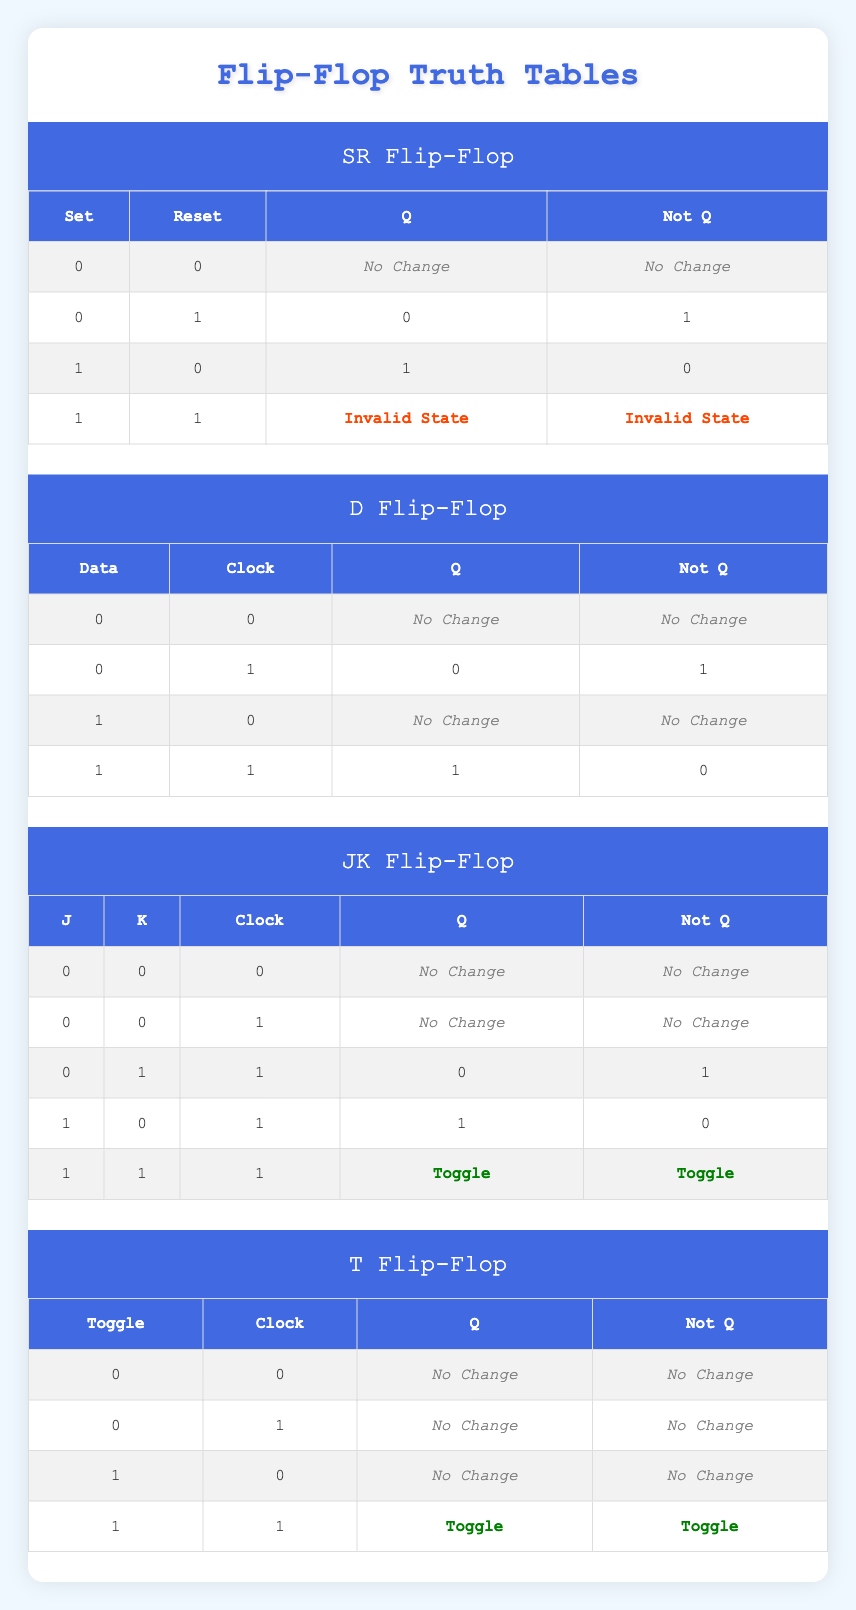What happens to Q and Not Q when both Set and Reset are 1 in an SR Flip-Flop? When both Set and Reset inputs are 1, the truth table indicates that the outputs Q and Not Q enter an Invalid State. This is specified in the fourth row of the SR Flip-Flop section of the truth table.
Answer: Invalid State In a D Flip-Flop, what is the output Q when the Data input is 1 and the Clock input is 1? According to the D Flip-Flop truth table, when the Data input is 1 and the Clock input is 1, the output Q is 1 as stated in the last row of the corresponding section.
Answer: 1 True or False: In a JK Flip-Flop, if J and K are both 1 while the Clock is also 1, the output Q remains the same. The truth table for the JK Flip-Flop indicates that when J and K are both 1, and the Clock input is 1, the output Q toggles, meaning it does not remain the same. Therefore, the answer is False.
Answer: False For the T Flip-Flop, when the Toggle input is 1 and the Clock input is 0, what are the values of Q and Not Q? The T Flip-Flop's truth table shows that when the Toggle input is 1 and the Clock is 0, the outputs Q and Not Q remain unchanged, which is noted as "No Change" in the third row of its section.
Answer: No Change What is the output Q in an SR Flip-Flop if Set is 0 and Reset is 0? In the case where both Set and Reset inputs are 0, the truth table for the SR Flip-Flop indicates that the output Q does not change, which is documented as "No Change."
Answer: No Change How many total unique combinations of inputs are valid for a JK Flip-Flop? To determine the total unique valid input combinations for a JK Flip-Flop, we should consider the combinations of J (0 and 1), K (0 and 1), and Clock (0 and 1). This gives us 2 (for J) x 2 (for K) x 2 (for Clock) = 8 unique combinations.
Answer: 8 In a D Flip-Flop, compare the outputs Q and Not Q when Data is 0 and Clock is 1; what are the values? The D Flip-Flop truth table shows that when the Data input is 0 and the Clock is 1, Q is 0 and Not Q is 1, as seen in the second row of the truth table.
Answer: Q: 0, Not Q: 1 True or False: The JK Flip-Flop outputs the same values for Q and Not Q when J is 0, K is 0, and the Clock is 0. The truth table for the JK Flip-Flop states that when J is 0, K is 0, and Clock is 0, both outputs Q and Not Q indicate "No Change." This is true, as both outputs remain the same under these conditions.
Answer: True What are the outputs Q and Not Q for a T Flip-Flop when the Toggle input is 0 and Clock is 1? When the Toggle input is 0 and the Clock is 1 in the T Flip-Flop, the truth table indicates that both Q and Not Q maintain their values, shown as "No Change" in the second row of the truth table.
Answer: No Change 